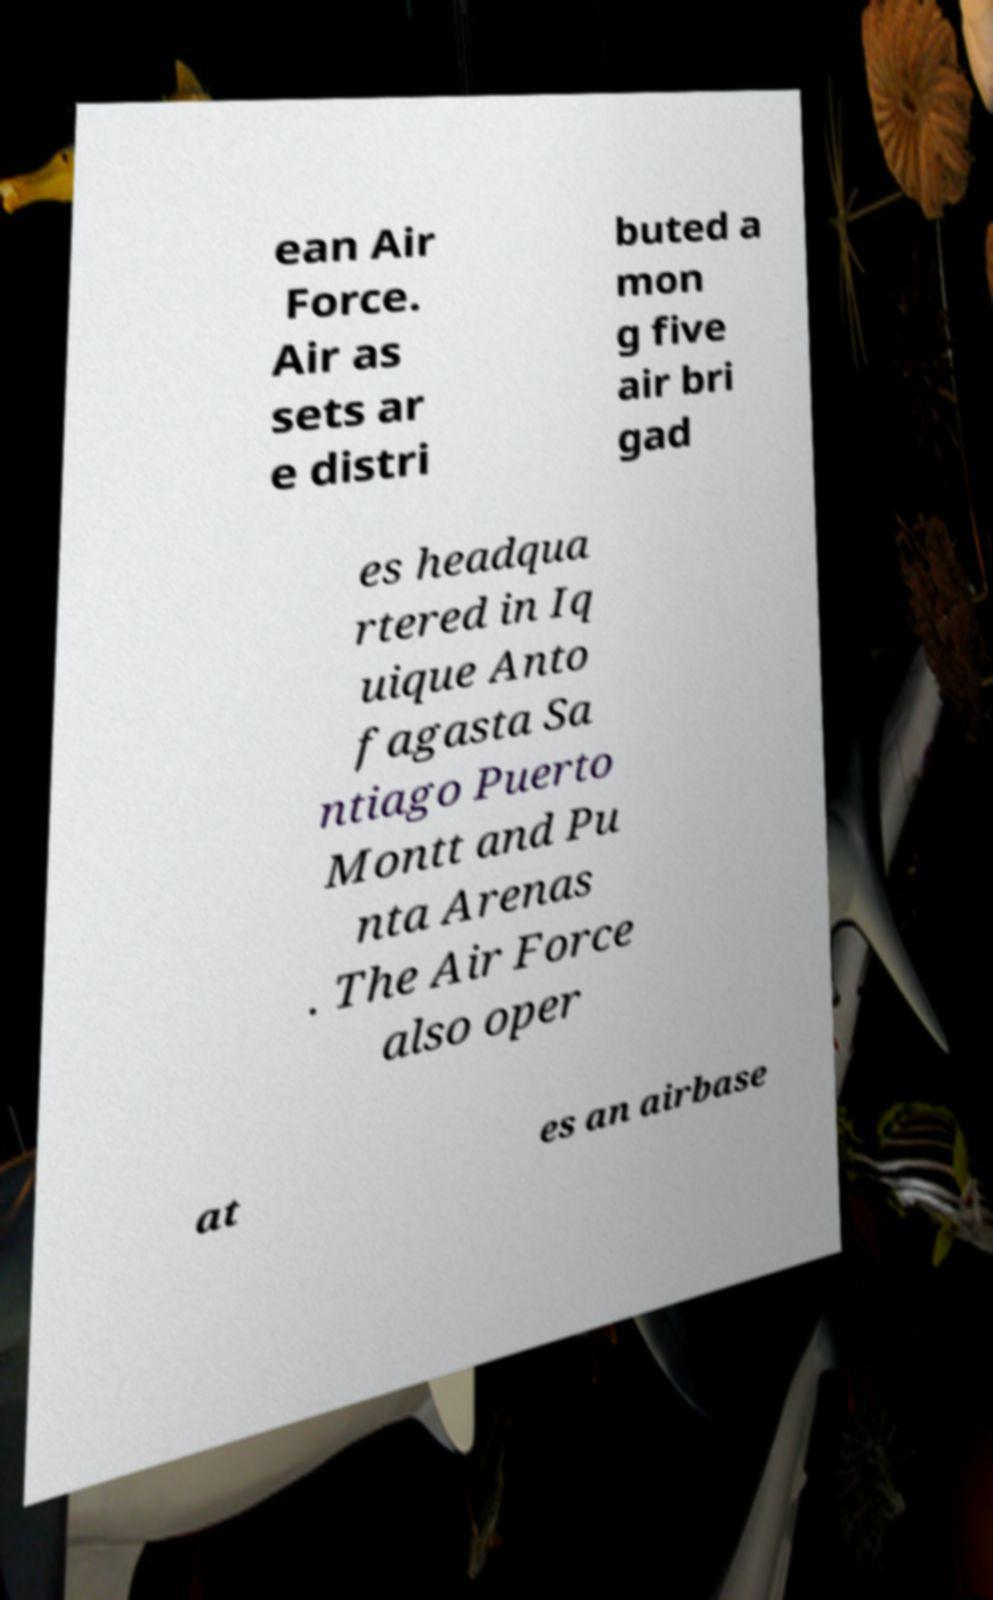Please identify and transcribe the text found in this image. ean Air Force. Air as sets ar e distri buted a mon g five air bri gad es headqua rtered in Iq uique Anto fagasta Sa ntiago Puerto Montt and Pu nta Arenas . The Air Force also oper at es an airbase 